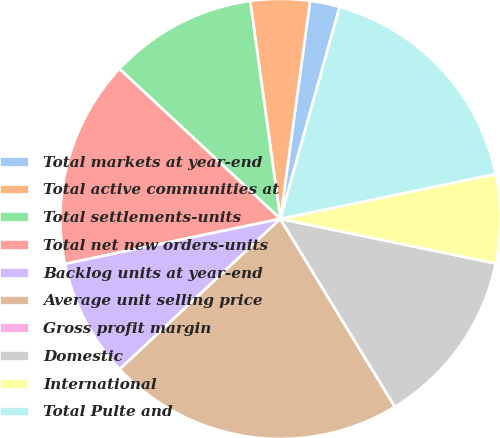<chart> <loc_0><loc_0><loc_500><loc_500><pie_chart><fcel>Total markets at year-end<fcel>Total active communities at<fcel>Total settlements-units<fcel>Total net new orders-units<fcel>Backlog units at year-end<fcel>Average unit selling price<fcel>Gross profit margin<fcel>Domestic<fcel>International<fcel>Total Pulte and<nl><fcel>2.18%<fcel>4.35%<fcel>10.87%<fcel>15.22%<fcel>8.7%<fcel>21.74%<fcel>0.0%<fcel>13.04%<fcel>6.52%<fcel>17.39%<nl></chart> 